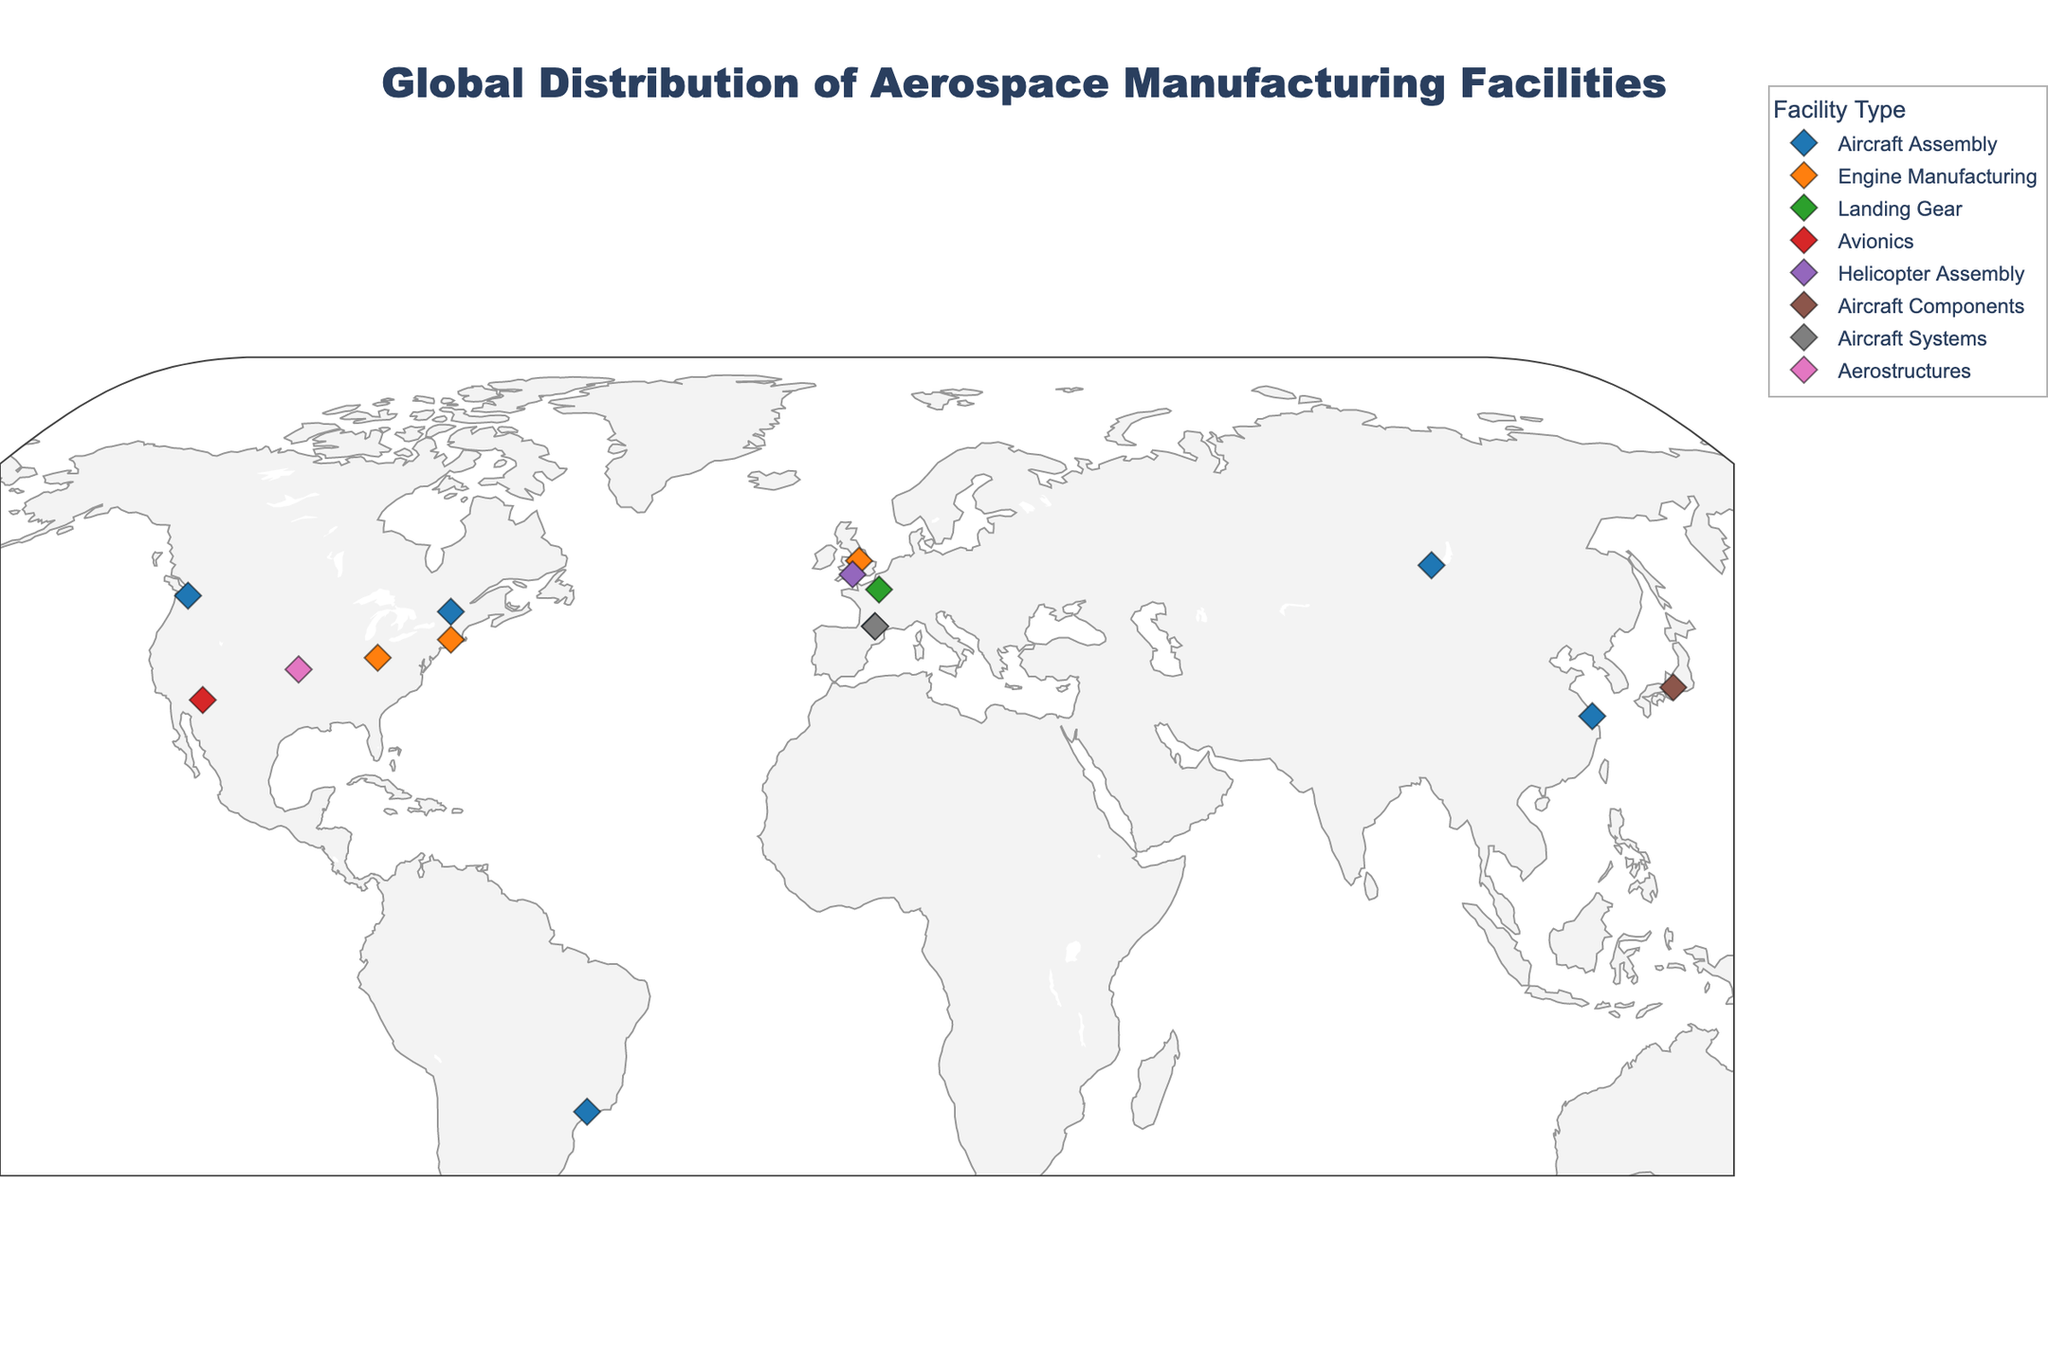what is the title of the plot? The title is located at the top of the figure and summarizes the content of the plot. The large font size helps it stand out.
Answer: Global Distribution of Aerospace Manufacturing Facilities What types of aerospace manufacturing facilities are shown on the map? The types of facilities are indicated using different colors and listed in the legend. This legend categorizes each type of facility.
Answer: Aircraft Assembly, Engine Manufacturing, Landing Gear, Avionics, Helicopter Assembly, Aircraft Components, Aerostructures, Aircraft Systems How many assembly-type facilities are depicted in total? By observing the color associated with assembly-type facilities and counting the markers of that color, one can tally the total number. Assembly is generally indicated by the dark blue color according to the legend.
Answer: 7 Which country has the highest number of aerospace manufacturing facilities on the map? By examining the countries tied to each facility on the map, one can count the occurrences for each country and identify the one with the maximum count.
Answer: USA What is the latitude and longitude of the facility in Japan? The facility's coordinates can be found by hovering over the facility marker in Japan on the map, where the geographical information is displayed.
Answer: Latitude: 35.1815, Longitude: 136.9066 How many facilities are involved in engine manufacturing? By identifying the color associated with engine manufacturing (typically orange) from the legend and counting the corresponding markers on the map, the total number can be found.
Answer: 3 Which facility is located at approximately 50 degrees north and 2 degrees west? By examining the geographical markers on the plot near these coordinates and referring to their hover data, one can determine the name and type of the facility.
Answer: Leonardo Helicopters Yeovil Is there any aerospace manufacturing facility in South America? By looking at the geographical distribution on the map, particularly the region representing South America, one can identify if any facility marker is present there.
Answer: Yes, Embraer São José dos Campos in Brazil Comparing USA and France, which one has more diversity in facility types? By counting and comparing the number of different types of facilities (indicated by different colors) in each country, one can determine which country has more facility type variety.
Answer: USA How many engine manufacturing facilities are located in the United Kingdom? Upon locating the facilities in the United Kingdom on the map and identifying those involved in engine manufacturing, the total number can be counted. The color representing engine manufacturing helps in this identification.
Answer: 1 